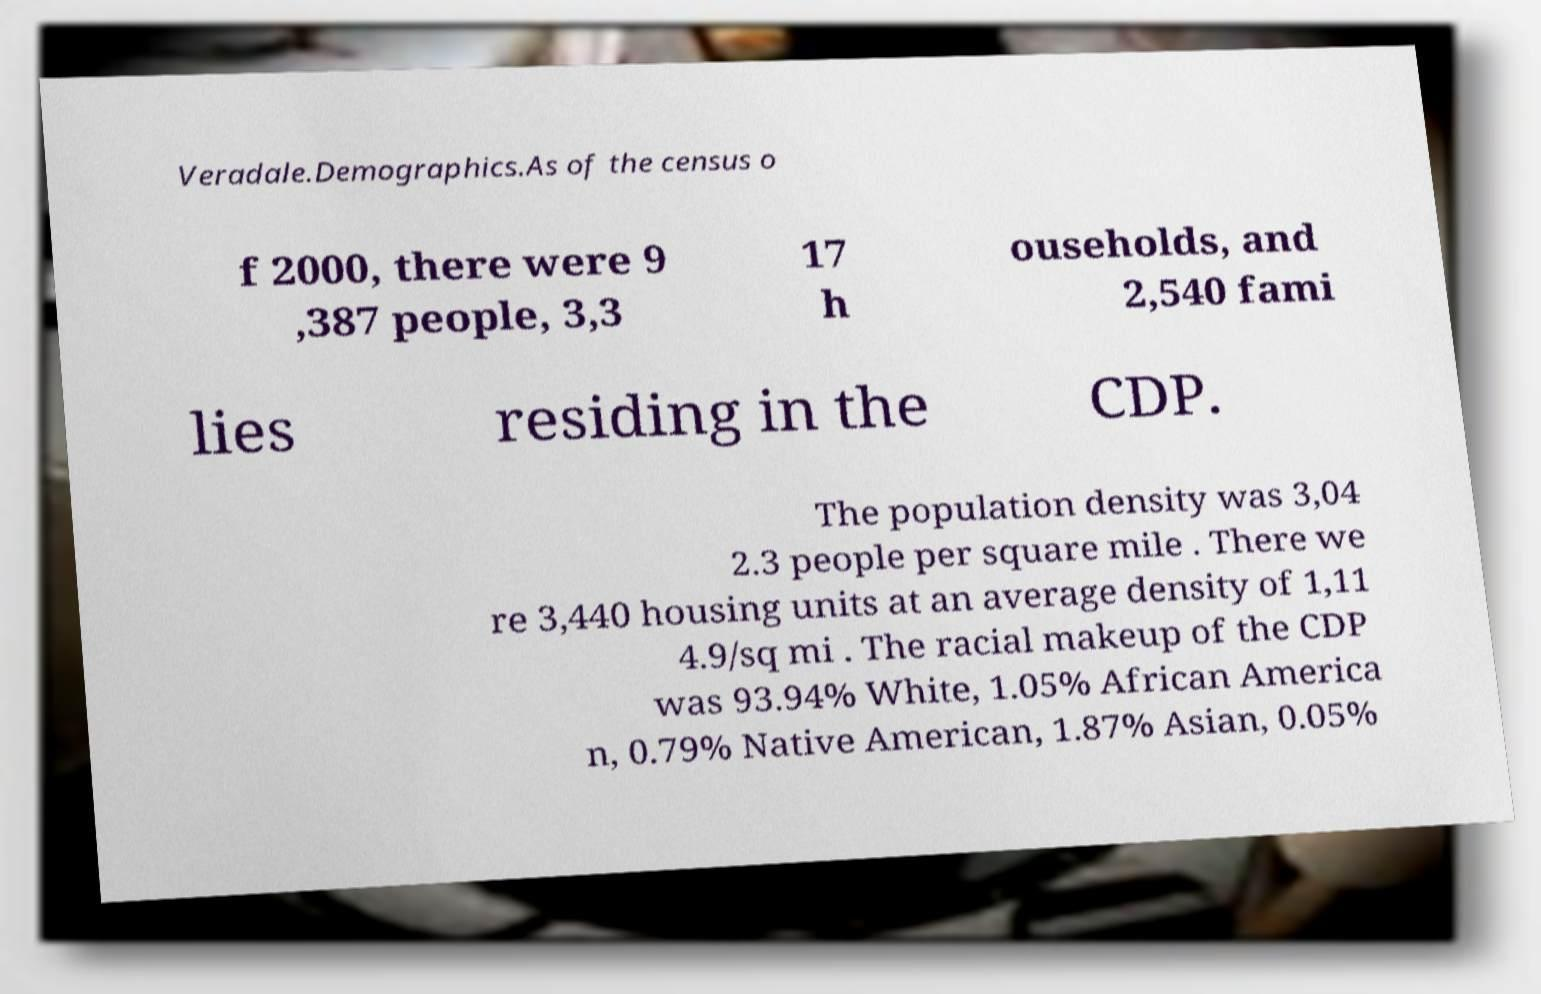I need the written content from this picture converted into text. Can you do that? Veradale.Demographics.As of the census o f 2000, there were 9 ,387 people, 3,3 17 h ouseholds, and 2,540 fami lies residing in the CDP. The population density was 3,04 2.3 people per square mile . There we re 3,440 housing units at an average density of 1,11 4.9/sq mi . The racial makeup of the CDP was 93.94% White, 1.05% African America n, 0.79% Native American, 1.87% Asian, 0.05% 